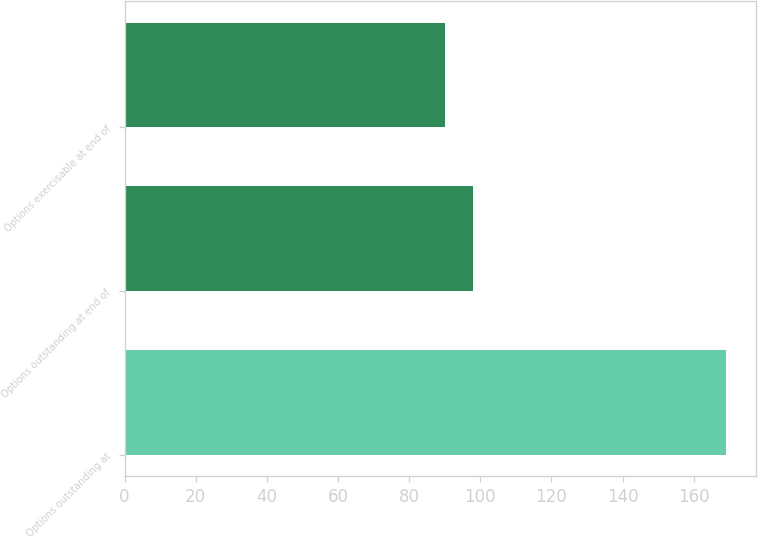<chart> <loc_0><loc_0><loc_500><loc_500><bar_chart><fcel>Options outstanding at<fcel>Options outstanding at end of<fcel>Options exercisable at end of<nl><fcel>169<fcel>97.9<fcel>90<nl></chart> 